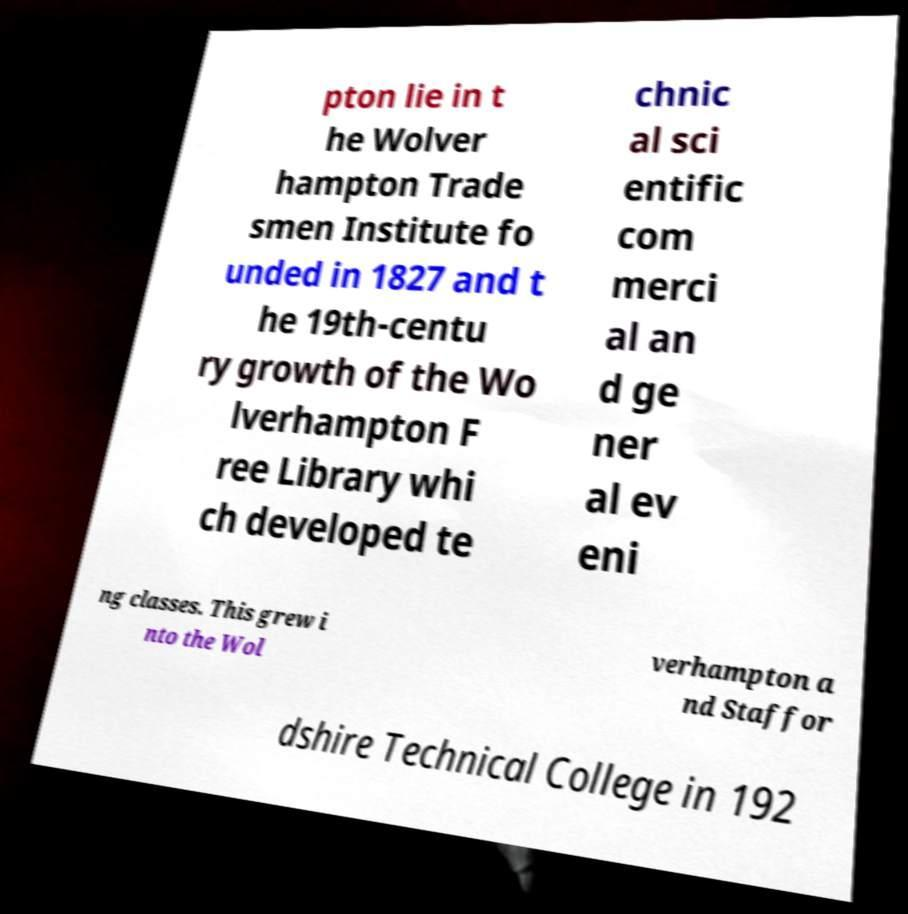What messages or text are displayed in this image? I need them in a readable, typed format. pton lie in t he Wolver hampton Trade smen Institute fo unded in 1827 and t he 19th-centu ry growth of the Wo lverhampton F ree Library whi ch developed te chnic al sci entific com merci al an d ge ner al ev eni ng classes. This grew i nto the Wol verhampton a nd Staffor dshire Technical College in 192 